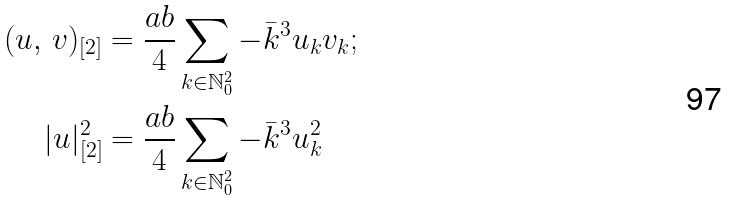Convert formula to latex. <formula><loc_0><loc_0><loc_500><loc_500>( u , \, v ) _ { [ 2 ] } & = \frac { a b } { 4 } \sum _ { k \in \mathbb { N } _ { 0 } ^ { 2 } } - \bar { k } ^ { 3 } u _ { k } v _ { k } ; \\ | u | _ { [ 2 ] } ^ { 2 } & = \frac { a b } { 4 } \sum _ { k \in \mathbb { N } _ { 0 } ^ { 2 } } - \bar { k } ^ { 3 } u _ { k } ^ { 2 }</formula> 